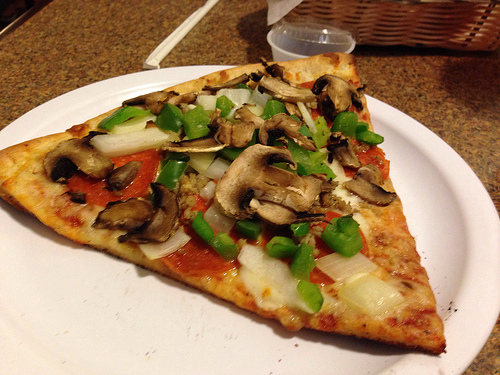You have the chance to turn this pizza into a magical artifact. What properties would it have? The Enchanted Slice: This magical pizza has the power to bring people together and mend broken relationships. Each topping bestows a unique trait upon the eater: the mushrooms grant wisdom, the bell peppers provide courage, the onions offer insight into one's emotions, and the pepperoni enhances strength and resilience. When shared among friends and family, this pizza creates an unbreakable bond, filling hearts with warmth, understanding, and a touch of enchantment. Craft a small poem based on the image. Upon a simple plate it lies,
A slice of joy beneath my eyes.
With mushrooms, peppers, onions sweet,
And pepperoni, such a treat.
In humble form, its flavors blend,
A timeless feast that knows no end. Imagine this image is a scene from a critical moment in a film. Describe the characters and their actions. In the dim light of a small pizzeria, Sarah and Tom, two estranged siblings, sit across from each other. The pizza between them serves as a bridge to rekindle their bond. Sarah, with tears in her eyes, reaches for a slice as Tom avoids her gaze, his heart heavy with years of misunderstandings. A single slice of pizza, loaded with their favorite childhood toppings, acts as a catalyst for heartfelt confessions and healing. As they share the meal, they begin to unearth sentiments long buried, finding solace and connection in each other's presence. 